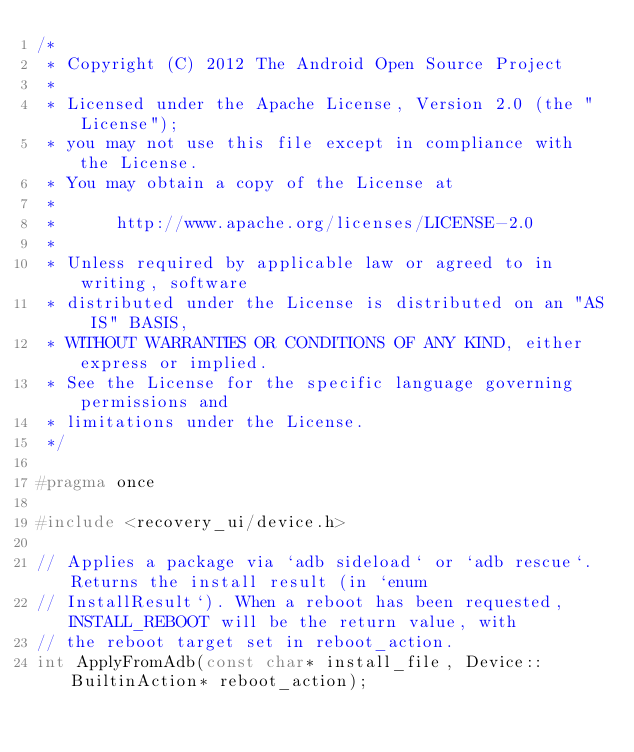Convert code to text. <code><loc_0><loc_0><loc_500><loc_500><_C_>/*
 * Copyright (C) 2012 The Android Open Source Project
 *
 * Licensed under the Apache License, Version 2.0 (the "License");
 * you may not use this file except in compliance with the License.
 * You may obtain a copy of the License at
 *
 *      http://www.apache.org/licenses/LICENSE-2.0
 *
 * Unless required by applicable law or agreed to in writing, software
 * distributed under the License is distributed on an "AS IS" BASIS,
 * WITHOUT WARRANTIES OR CONDITIONS OF ANY KIND, either express or implied.
 * See the License for the specific language governing permissions and
 * limitations under the License.
 */

#pragma once

#include <recovery_ui/device.h>

// Applies a package via `adb sideload` or `adb rescue`. Returns the install result (in `enum
// InstallResult`). When a reboot has been requested, INSTALL_REBOOT will be the return value, with
// the reboot target set in reboot_action.
int ApplyFromAdb(const char* install_file, Device::BuiltinAction* reboot_action);
</code> 